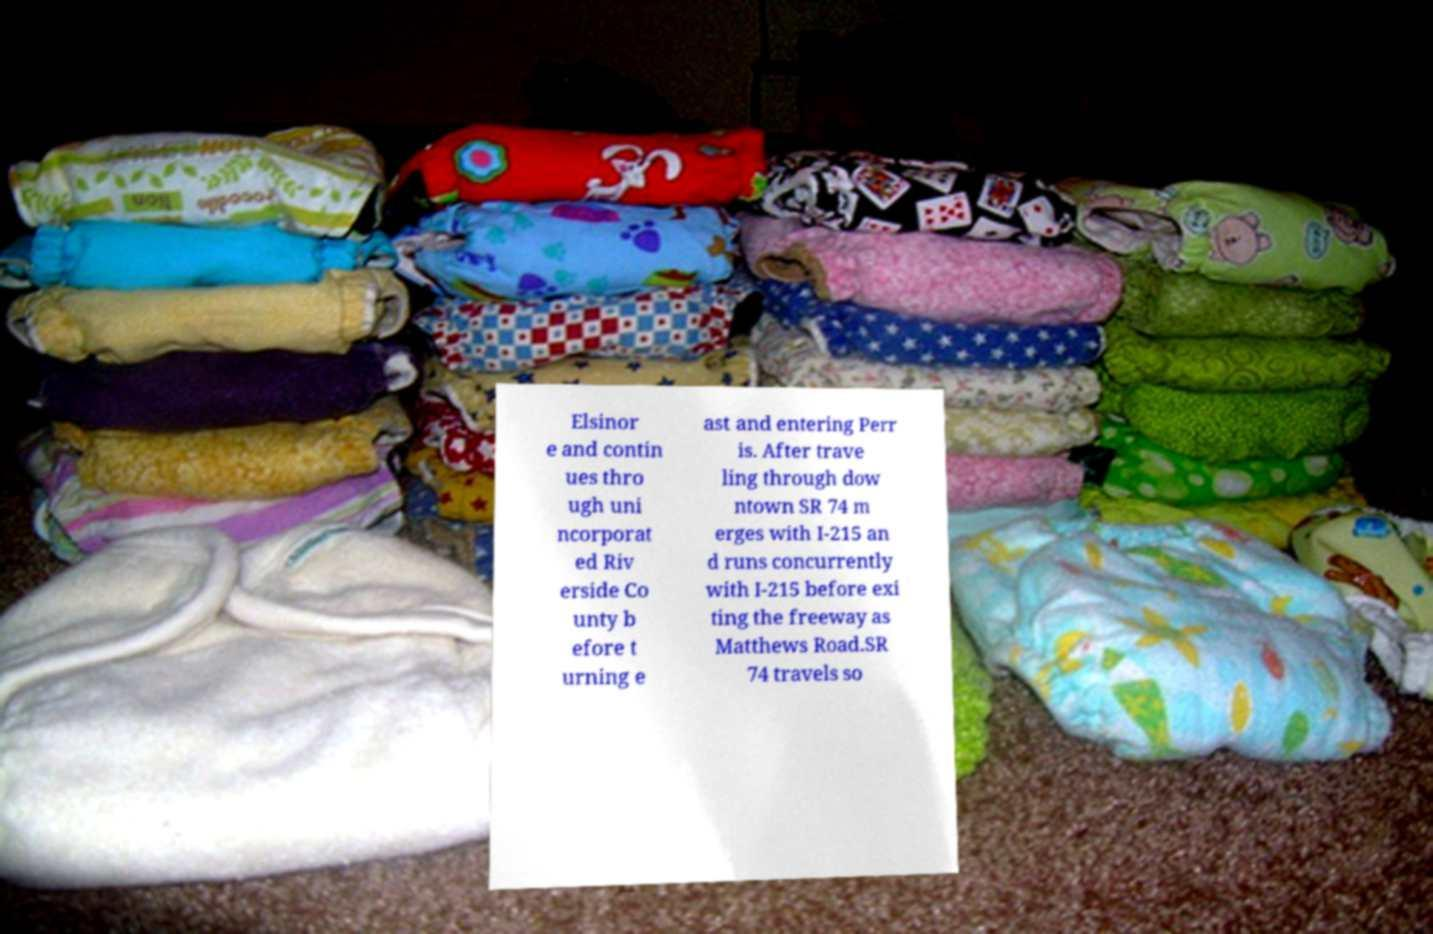For documentation purposes, I need the text within this image transcribed. Could you provide that? Elsinor e and contin ues thro ugh uni ncorporat ed Riv erside Co unty b efore t urning e ast and entering Perr is. After trave ling through dow ntown SR 74 m erges with I-215 an d runs concurrently with I-215 before exi ting the freeway as Matthews Road.SR 74 travels so 